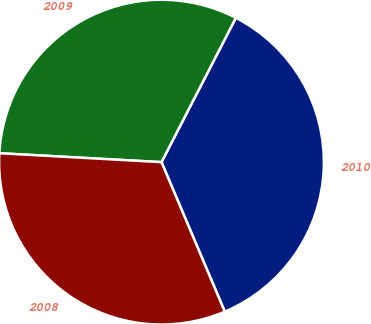Convert chart. <chart><loc_0><loc_0><loc_500><loc_500><pie_chart><fcel>2010<fcel>2009<fcel>2008<nl><fcel>36.05%<fcel>31.7%<fcel>32.25%<nl></chart> 